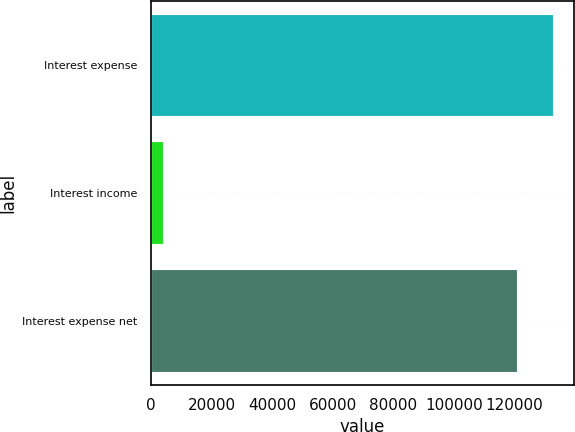Convert chart. <chart><loc_0><loc_0><loc_500><loc_500><bar_chart><fcel>Interest expense<fcel>Interest income<fcel>Interest expense net<nl><fcel>132816<fcel>3905<fcel>120742<nl></chart> 